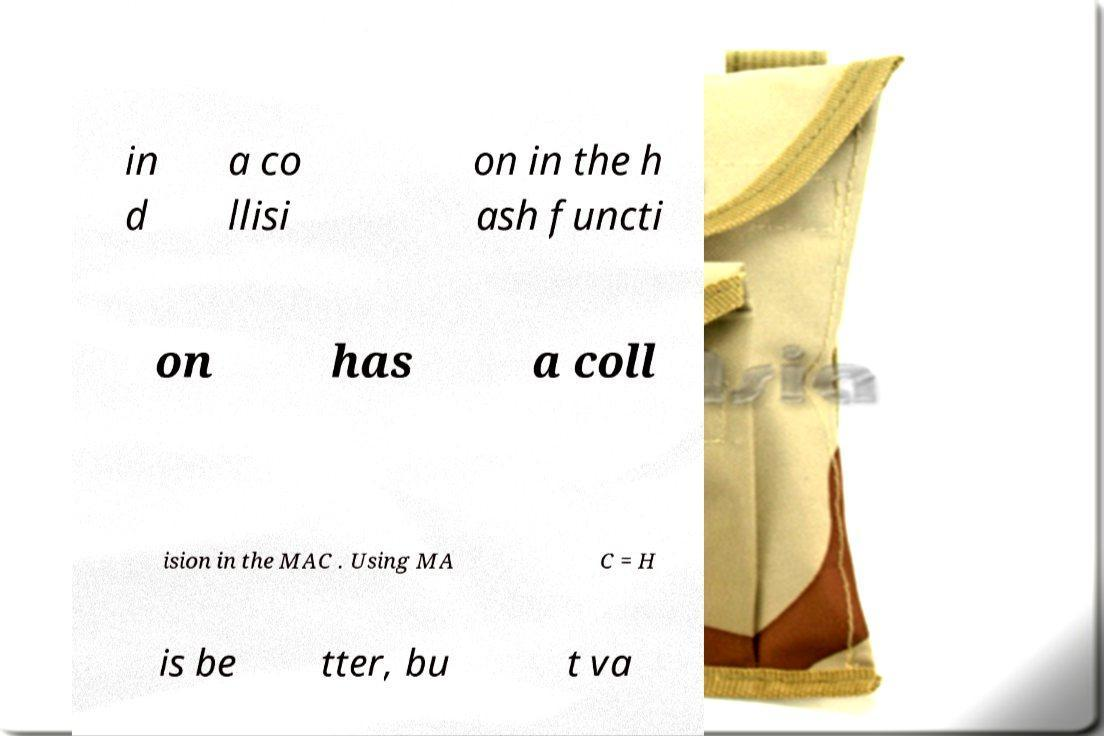Can you accurately transcribe the text from the provided image for me? in d a co llisi on in the h ash functi on has a coll ision in the MAC . Using MA C = H is be tter, bu t va 